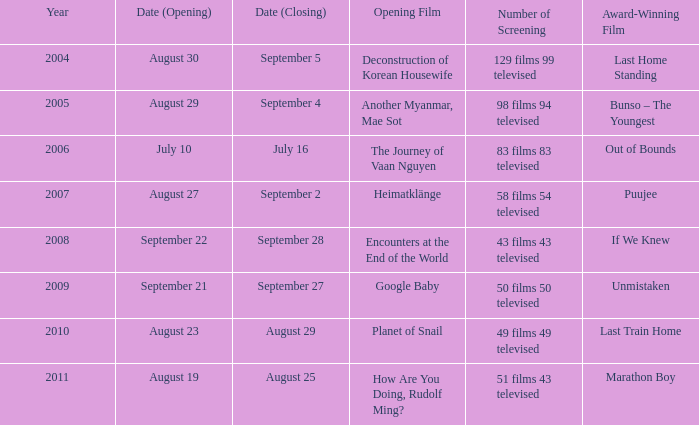How many screenings does the opening film of the journey of vaan nguyen have? 1.0. 